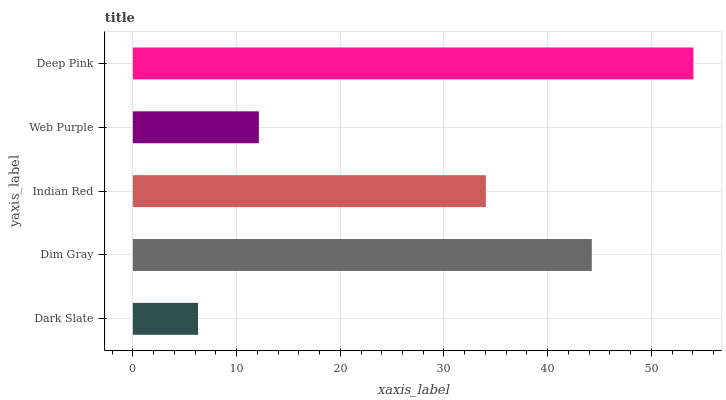Is Dark Slate the minimum?
Answer yes or no. Yes. Is Deep Pink the maximum?
Answer yes or no. Yes. Is Dim Gray the minimum?
Answer yes or no. No. Is Dim Gray the maximum?
Answer yes or no. No. Is Dim Gray greater than Dark Slate?
Answer yes or no. Yes. Is Dark Slate less than Dim Gray?
Answer yes or no. Yes. Is Dark Slate greater than Dim Gray?
Answer yes or no. No. Is Dim Gray less than Dark Slate?
Answer yes or no. No. Is Indian Red the high median?
Answer yes or no. Yes. Is Indian Red the low median?
Answer yes or no. Yes. Is Web Purple the high median?
Answer yes or no. No. Is Web Purple the low median?
Answer yes or no. No. 